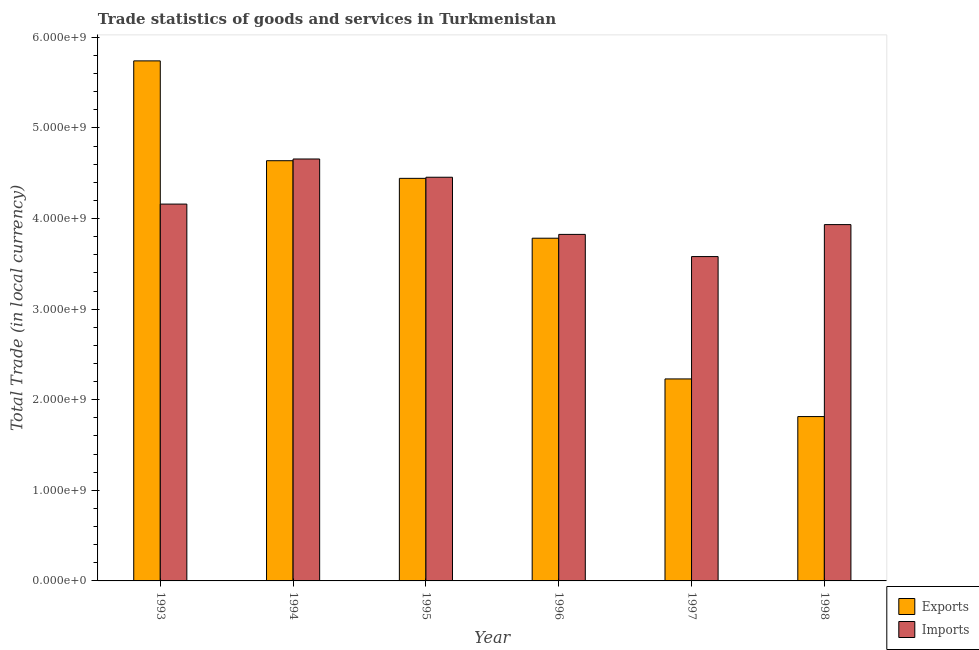How many different coloured bars are there?
Make the answer very short. 2. How many bars are there on the 6th tick from the right?
Give a very brief answer. 2. In how many cases, is the number of bars for a given year not equal to the number of legend labels?
Your response must be concise. 0. What is the export of goods and services in 1996?
Provide a short and direct response. 3.78e+09. Across all years, what is the maximum export of goods and services?
Your answer should be very brief. 5.74e+09. Across all years, what is the minimum imports of goods and services?
Ensure brevity in your answer.  3.58e+09. In which year was the imports of goods and services maximum?
Your answer should be very brief. 1994. In which year was the imports of goods and services minimum?
Your answer should be very brief. 1997. What is the total imports of goods and services in the graph?
Keep it short and to the point. 2.46e+1. What is the difference between the export of goods and services in 1995 and that in 1996?
Make the answer very short. 6.61e+08. What is the difference between the imports of goods and services in 1994 and the export of goods and services in 1996?
Keep it short and to the point. 8.33e+08. What is the average imports of goods and services per year?
Give a very brief answer. 4.10e+09. In the year 1994, what is the difference between the imports of goods and services and export of goods and services?
Your answer should be compact. 0. What is the ratio of the export of goods and services in 1993 to that in 1994?
Your response must be concise. 1.24. Is the difference between the imports of goods and services in 1995 and 1997 greater than the difference between the export of goods and services in 1995 and 1997?
Your response must be concise. No. What is the difference between the highest and the second highest export of goods and services?
Provide a succinct answer. 1.10e+09. What is the difference between the highest and the lowest export of goods and services?
Provide a short and direct response. 3.93e+09. What does the 1st bar from the left in 1994 represents?
Ensure brevity in your answer.  Exports. What does the 2nd bar from the right in 1993 represents?
Keep it short and to the point. Exports. How many bars are there?
Keep it short and to the point. 12. Does the graph contain any zero values?
Make the answer very short. No. Does the graph contain grids?
Your response must be concise. No. Where does the legend appear in the graph?
Keep it short and to the point. Bottom right. How are the legend labels stacked?
Provide a short and direct response. Vertical. What is the title of the graph?
Give a very brief answer. Trade statistics of goods and services in Turkmenistan. Does "Arms exports" appear as one of the legend labels in the graph?
Your answer should be compact. No. What is the label or title of the Y-axis?
Your answer should be very brief. Total Trade (in local currency). What is the Total Trade (in local currency) of Exports in 1993?
Ensure brevity in your answer.  5.74e+09. What is the Total Trade (in local currency) in Imports in 1993?
Give a very brief answer. 4.16e+09. What is the Total Trade (in local currency) of Exports in 1994?
Keep it short and to the point. 4.64e+09. What is the Total Trade (in local currency) in Imports in 1994?
Provide a succinct answer. 4.66e+09. What is the Total Trade (in local currency) in Exports in 1995?
Provide a succinct answer. 4.44e+09. What is the Total Trade (in local currency) in Imports in 1995?
Give a very brief answer. 4.46e+09. What is the Total Trade (in local currency) of Exports in 1996?
Give a very brief answer. 3.78e+09. What is the Total Trade (in local currency) in Imports in 1996?
Make the answer very short. 3.83e+09. What is the Total Trade (in local currency) in Exports in 1997?
Make the answer very short. 2.23e+09. What is the Total Trade (in local currency) of Imports in 1997?
Ensure brevity in your answer.  3.58e+09. What is the Total Trade (in local currency) in Exports in 1998?
Give a very brief answer. 1.81e+09. What is the Total Trade (in local currency) of Imports in 1998?
Ensure brevity in your answer.  3.93e+09. Across all years, what is the maximum Total Trade (in local currency) of Exports?
Offer a very short reply. 5.74e+09. Across all years, what is the maximum Total Trade (in local currency) in Imports?
Provide a short and direct response. 4.66e+09. Across all years, what is the minimum Total Trade (in local currency) in Exports?
Give a very brief answer. 1.81e+09. Across all years, what is the minimum Total Trade (in local currency) in Imports?
Ensure brevity in your answer.  3.58e+09. What is the total Total Trade (in local currency) in Exports in the graph?
Give a very brief answer. 2.27e+1. What is the total Total Trade (in local currency) in Imports in the graph?
Give a very brief answer. 2.46e+1. What is the difference between the Total Trade (in local currency) in Exports in 1993 and that in 1994?
Ensure brevity in your answer.  1.10e+09. What is the difference between the Total Trade (in local currency) of Imports in 1993 and that in 1994?
Offer a terse response. -4.98e+08. What is the difference between the Total Trade (in local currency) of Exports in 1993 and that in 1995?
Your answer should be very brief. 1.30e+09. What is the difference between the Total Trade (in local currency) of Imports in 1993 and that in 1995?
Keep it short and to the point. -2.96e+08. What is the difference between the Total Trade (in local currency) in Exports in 1993 and that in 1996?
Your answer should be very brief. 1.96e+09. What is the difference between the Total Trade (in local currency) of Imports in 1993 and that in 1996?
Offer a very short reply. 3.35e+08. What is the difference between the Total Trade (in local currency) in Exports in 1993 and that in 1997?
Your response must be concise. 3.51e+09. What is the difference between the Total Trade (in local currency) in Imports in 1993 and that in 1997?
Give a very brief answer. 5.79e+08. What is the difference between the Total Trade (in local currency) in Exports in 1993 and that in 1998?
Provide a short and direct response. 3.93e+09. What is the difference between the Total Trade (in local currency) of Imports in 1993 and that in 1998?
Your response must be concise. 2.26e+08. What is the difference between the Total Trade (in local currency) of Exports in 1994 and that in 1995?
Provide a succinct answer. 1.95e+08. What is the difference between the Total Trade (in local currency) in Imports in 1994 and that in 1995?
Offer a terse response. 2.01e+08. What is the difference between the Total Trade (in local currency) in Exports in 1994 and that in 1996?
Make the answer very short. 8.56e+08. What is the difference between the Total Trade (in local currency) of Imports in 1994 and that in 1996?
Keep it short and to the point. 8.33e+08. What is the difference between the Total Trade (in local currency) of Exports in 1994 and that in 1997?
Keep it short and to the point. 2.41e+09. What is the difference between the Total Trade (in local currency) in Imports in 1994 and that in 1997?
Give a very brief answer. 1.08e+09. What is the difference between the Total Trade (in local currency) of Exports in 1994 and that in 1998?
Give a very brief answer. 2.82e+09. What is the difference between the Total Trade (in local currency) of Imports in 1994 and that in 1998?
Keep it short and to the point. 7.24e+08. What is the difference between the Total Trade (in local currency) of Exports in 1995 and that in 1996?
Provide a short and direct response. 6.61e+08. What is the difference between the Total Trade (in local currency) of Imports in 1995 and that in 1996?
Make the answer very short. 6.31e+08. What is the difference between the Total Trade (in local currency) of Exports in 1995 and that in 1997?
Provide a short and direct response. 2.21e+09. What is the difference between the Total Trade (in local currency) of Imports in 1995 and that in 1997?
Make the answer very short. 8.76e+08. What is the difference between the Total Trade (in local currency) in Exports in 1995 and that in 1998?
Make the answer very short. 2.63e+09. What is the difference between the Total Trade (in local currency) of Imports in 1995 and that in 1998?
Ensure brevity in your answer.  5.23e+08. What is the difference between the Total Trade (in local currency) of Exports in 1996 and that in 1997?
Give a very brief answer. 1.55e+09. What is the difference between the Total Trade (in local currency) in Imports in 1996 and that in 1997?
Make the answer very short. 2.45e+08. What is the difference between the Total Trade (in local currency) in Exports in 1996 and that in 1998?
Your answer should be compact. 1.97e+09. What is the difference between the Total Trade (in local currency) of Imports in 1996 and that in 1998?
Your response must be concise. -1.08e+08. What is the difference between the Total Trade (in local currency) in Exports in 1997 and that in 1998?
Your answer should be very brief. 4.16e+08. What is the difference between the Total Trade (in local currency) of Imports in 1997 and that in 1998?
Provide a succinct answer. -3.53e+08. What is the difference between the Total Trade (in local currency) of Exports in 1993 and the Total Trade (in local currency) of Imports in 1994?
Offer a very short reply. 1.08e+09. What is the difference between the Total Trade (in local currency) of Exports in 1993 and the Total Trade (in local currency) of Imports in 1995?
Give a very brief answer. 1.28e+09. What is the difference between the Total Trade (in local currency) in Exports in 1993 and the Total Trade (in local currency) in Imports in 1996?
Your answer should be very brief. 1.92e+09. What is the difference between the Total Trade (in local currency) in Exports in 1993 and the Total Trade (in local currency) in Imports in 1997?
Your response must be concise. 2.16e+09. What is the difference between the Total Trade (in local currency) in Exports in 1993 and the Total Trade (in local currency) in Imports in 1998?
Provide a short and direct response. 1.81e+09. What is the difference between the Total Trade (in local currency) of Exports in 1994 and the Total Trade (in local currency) of Imports in 1995?
Give a very brief answer. 1.82e+08. What is the difference between the Total Trade (in local currency) in Exports in 1994 and the Total Trade (in local currency) in Imports in 1996?
Provide a succinct answer. 8.14e+08. What is the difference between the Total Trade (in local currency) of Exports in 1994 and the Total Trade (in local currency) of Imports in 1997?
Your response must be concise. 1.06e+09. What is the difference between the Total Trade (in local currency) in Exports in 1994 and the Total Trade (in local currency) in Imports in 1998?
Provide a succinct answer. 7.05e+08. What is the difference between the Total Trade (in local currency) in Exports in 1995 and the Total Trade (in local currency) in Imports in 1996?
Keep it short and to the point. 6.19e+08. What is the difference between the Total Trade (in local currency) in Exports in 1995 and the Total Trade (in local currency) in Imports in 1997?
Ensure brevity in your answer.  8.63e+08. What is the difference between the Total Trade (in local currency) of Exports in 1995 and the Total Trade (in local currency) of Imports in 1998?
Keep it short and to the point. 5.10e+08. What is the difference between the Total Trade (in local currency) of Exports in 1996 and the Total Trade (in local currency) of Imports in 1997?
Provide a short and direct response. 2.03e+08. What is the difference between the Total Trade (in local currency) in Exports in 1996 and the Total Trade (in local currency) in Imports in 1998?
Give a very brief answer. -1.50e+08. What is the difference between the Total Trade (in local currency) in Exports in 1997 and the Total Trade (in local currency) in Imports in 1998?
Provide a short and direct response. -1.70e+09. What is the average Total Trade (in local currency) in Exports per year?
Ensure brevity in your answer.  3.78e+09. What is the average Total Trade (in local currency) in Imports per year?
Provide a succinct answer. 4.10e+09. In the year 1993, what is the difference between the Total Trade (in local currency) of Exports and Total Trade (in local currency) of Imports?
Ensure brevity in your answer.  1.58e+09. In the year 1994, what is the difference between the Total Trade (in local currency) in Exports and Total Trade (in local currency) in Imports?
Offer a very short reply. -1.90e+07. In the year 1995, what is the difference between the Total Trade (in local currency) of Exports and Total Trade (in local currency) of Imports?
Keep it short and to the point. -1.24e+07. In the year 1996, what is the difference between the Total Trade (in local currency) of Exports and Total Trade (in local currency) of Imports?
Your response must be concise. -4.20e+07. In the year 1997, what is the difference between the Total Trade (in local currency) of Exports and Total Trade (in local currency) of Imports?
Keep it short and to the point. -1.35e+09. In the year 1998, what is the difference between the Total Trade (in local currency) in Exports and Total Trade (in local currency) in Imports?
Make the answer very short. -2.12e+09. What is the ratio of the Total Trade (in local currency) of Exports in 1993 to that in 1994?
Your answer should be very brief. 1.24. What is the ratio of the Total Trade (in local currency) in Imports in 1993 to that in 1994?
Your answer should be compact. 0.89. What is the ratio of the Total Trade (in local currency) of Exports in 1993 to that in 1995?
Provide a short and direct response. 1.29. What is the ratio of the Total Trade (in local currency) of Imports in 1993 to that in 1995?
Keep it short and to the point. 0.93. What is the ratio of the Total Trade (in local currency) in Exports in 1993 to that in 1996?
Make the answer very short. 1.52. What is the ratio of the Total Trade (in local currency) in Imports in 1993 to that in 1996?
Your answer should be compact. 1.09. What is the ratio of the Total Trade (in local currency) in Exports in 1993 to that in 1997?
Provide a succinct answer. 2.57. What is the ratio of the Total Trade (in local currency) in Imports in 1993 to that in 1997?
Your answer should be compact. 1.16. What is the ratio of the Total Trade (in local currency) of Exports in 1993 to that in 1998?
Make the answer very short. 3.16. What is the ratio of the Total Trade (in local currency) of Imports in 1993 to that in 1998?
Keep it short and to the point. 1.06. What is the ratio of the Total Trade (in local currency) of Exports in 1994 to that in 1995?
Ensure brevity in your answer.  1.04. What is the ratio of the Total Trade (in local currency) in Imports in 1994 to that in 1995?
Offer a terse response. 1.05. What is the ratio of the Total Trade (in local currency) in Exports in 1994 to that in 1996?
Provide a succinct answer. 1.23. What is the ratio of the Total Trade (in local currency) in Imports in 1994 to that in 1996?
Offer a terse response. 1.22. What is the ratio of the Total Trade (in local currency) in Exports in 1994 to that in 1997?
Offer a very short reply. 2.08. What is the ratio of the Total Trade (in local currency) in Imports in 1994 to that in 1997?
Make the answer very short. 1.3. What is the ratio of the Total Trade (in local currency) of Exports in 1994 to that in 1998?
Your answer should be very brief. 2.56. What is the ratio of the Total Trade (in local currency) of Imports in 1994 to that in 1998?
Your response must be concise. 1.18. What is the ratio of the Total Trade (in local currency) in Exports in 1995 to that in 1996?
Offer a terse response. 1.17. What is the ratio of the Total Trade (in local currency) of Imports in 1995 to that in 1996?
Make the answer very short. 1.17. What is the ratio of the Total Trade (in local currency) of Exports in 1995 to that in 1997?
Ensure brevity in your answer.  1.99. What is the ratio of the Total Trade (in local currency) in Imports in 1995 to that in 1997?
Offer a terse response. 1.24. What is the ratio of the Total Trade (in local currency) in Exports in 1995 to that in 1998?
Ensure brevity in your answer.  2.45. What is the ratio of the Total Trade (in local currency) of Imports in 1995 to that in 1998?
Your response must be concise. 1.13. What is the ratio of the Total Trade (in local currency) of Exports in 1996 to that in 1997?
Your answer should be compact. 1.7. What is the ratio of the Total Trade (in local currency) in Imports in 1996 to that in 1997?
Offer a terse response. 1.07. What is the ratio of the Total Trade (in local currency) of Exports in 1996 to that in 1998?
Ensure brevity in your answer.  2.09. What is the ratio of the Total Trade (in local currency) of Imports in 1996 to that in 1998?
Your answer should be compact. 0.97. What is the ratio of the Total Trade (in local currency) in Exports in 1997 to that in 1998?
Make the answer very short. 1.23. What is the ratio of the Total Trade (in local currency) in Imports in 1997 to that in 1998?
Your response must be concise. 0.91. What is the difference between the highest and the second highest Total Trade (in local currency) of Exports?
Provide a short and direct response. 1.10e+09. What is the difference between the highest and the second highest Total Trade (in local currency) in Imports?
Provide a succinct answer. 2.01e+08. What is the difference between the highest and the lowest Total Trade (in local currency) in Exports?
Your answer should be very brief. 3.93e+09. What is the difference between the highest and the lowest Total Trade (in local currency) in Imports?
Make the answer very short. 1.08e+09. 